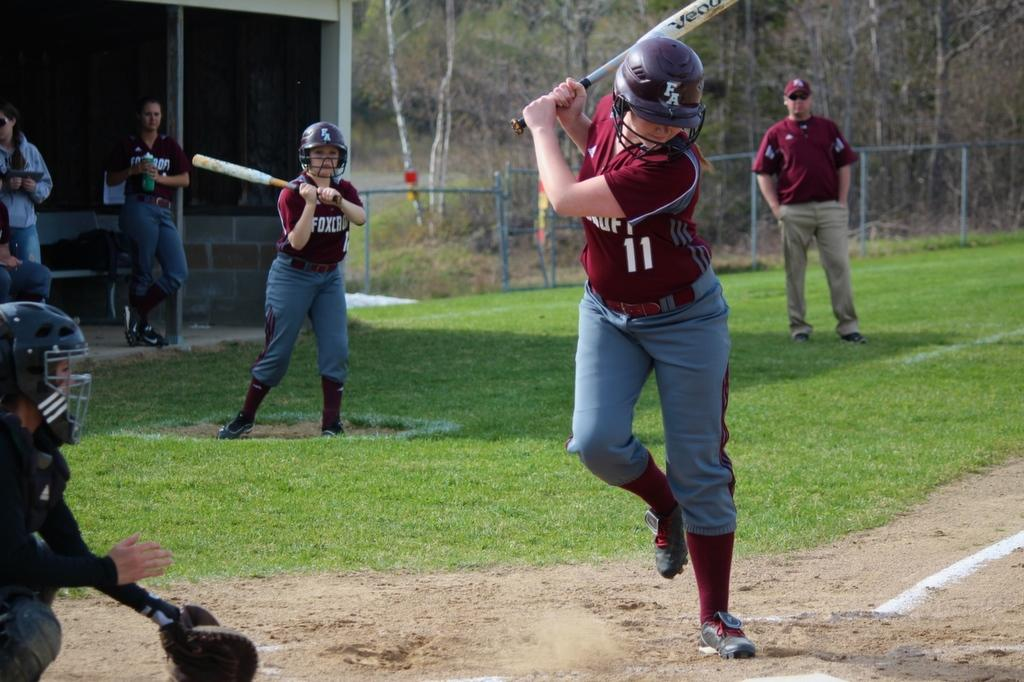Provide a one-sentence caption for the provided image. a person wearing the number 11 getting ready to swing. 